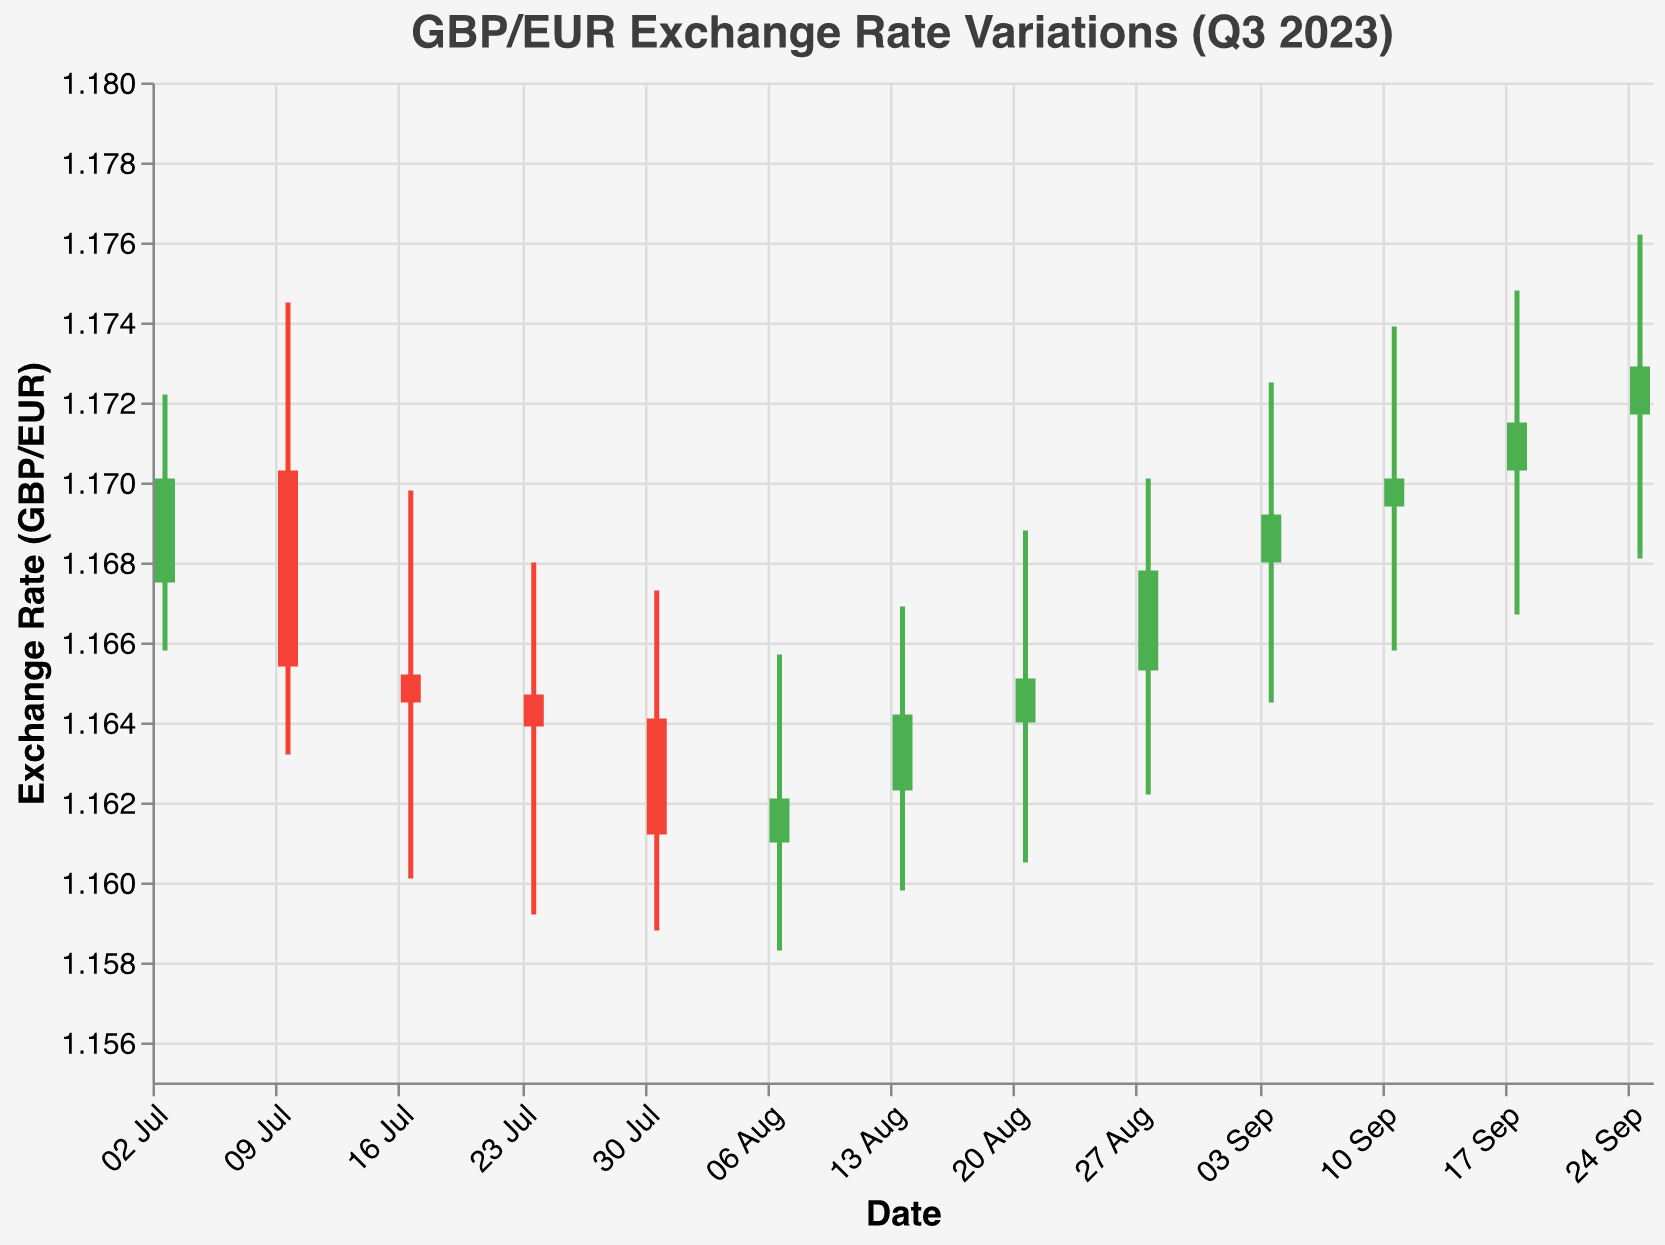What's the title of the chart? The title of the chart is displayed at the top, and it reads: "GBP/EUR Exchange Rate Variations (Q3 2023)."
Answer: GBP/EUR Exchange Rate Variations (Q3 2023) What does the y-axis represent? The y-axis represents the exchange rate between GBP and EUR, as indicated by the axis title "Exchange Rate (GBP/EUR)."
Answer: Exchange Rate (GBP/EUR) How many weekly data points are shown in the chart? Each weekly data point represents one OHLC bar, and there are data points from July 3rd, 2023, to September 25th, 2023. Counting the intervals between these dates, there are 13 data points in total.
Answer: 13 Which week had the highest closing exchange rate? To find the highest closing exchange rate, look at the position of the top of the bar for each week. The week of September 25th shows the highest point, with a closing rate of 1.1729.
Answer: Week of September 25th What is the range of the exchange rate on the week of September 18th? The range can be found by subtracting the low value from the high value for that week. The high was 1.1748, and the low was 1.1667, so the range is 1.1748 - 1.1667 = 0.0081.
Answer: 0.0081 Which week shows the largest difference between the high and the low values? To determine the largest difference, calculate the difference between the high and low values for each week and compare. For the week of July 10th, the high was 1.1745 and the low was 1.1632, resulting in a difference of 0.0113, which is the largest.
Answer: Week of July 10th On which weeks did the close rate exceed the open rate, and what color are those bars? Weeks where the close rate is higher than the open rate indicate a positive gain and these bars are green. By checking the data, these weeks are July 3rd, August 28th, September 4th, September 11th, September 18th, and September 25th.
Answer: Green Which week had the lowest closing exchange rate and what was it? Looking at the position of the bottom of the bars for each week, the week of July 31st has the lowest close value at 1.1612.
Answer: Week of July 31st, 1.1612 How does the height of the bars change over the weeks displayed in the chart? Over the weeks, the height of the bars, indicating the range between open and close rates, fluctuates with no consistent trend. Some weeks show taller bars (e.g., July 10th), whereas other weeks have shorter bars (e.g., July 31st).
Answer: Fluctuating with no consistent trend What's the average closing exchange rate for the entire time period shown in the chart? Sum the closing values for all weeks and divide by the number of weeks. The calculation is: (1.1701 + 1.1654 + 1.1645 + 1.1639 + 1.1612 + 1.1621 + 1.1642 + 1.1651 + 1.1678 + 1.1692 + 1.1701 + 1.1715 + 1.1729)/13 = 1.1667.
Answer: 1.1667 